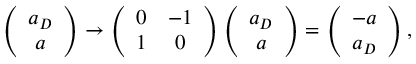Convert formula to latex. <formula><loc_0><loc_0><loc_500><loc_500>\left ( \begin{array} { c } { { a _ { D } } } \\ { a } \end{array} \right ) \rightarrow \left ( \begin{array} { c c } { 0 } & { - 1 } \\ { 1 } & { 0 } \end{array} \right ) \left ( \begin{array} { c } { { a _ { D } } } \\ { a } \end{array} \right ) = \left ( \begin{array} { c } { - a } \\ { { a _ { D } } } \end{array} \right ) ,</formula> 